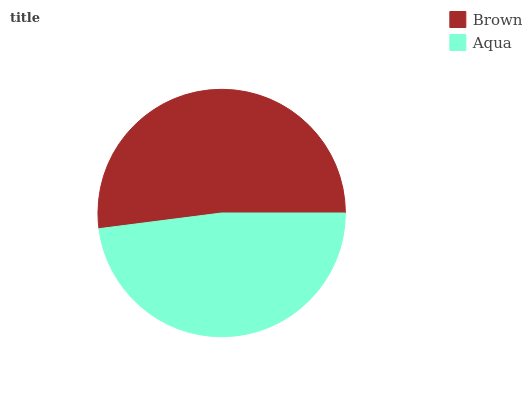Is Aqua the minimum?
Answer yes or no. Yes. Is Brown the maximum?
Answer yes or no. Yes. Is Aqua the maximum?
Answer yes or no. No. Is Brown greater than Aqua?
Answer yes or no. Yes. Is Aqua less than Brown?
Answer yes or no. Yes. Is Aqua greater than Brown?
Answer yes or no. No. Is Brown less than Aqua?
Answer yes or no. No. Is Brown the high median?
Answer yes or no. Yes. Is Aqua the low median?
Answer yes or no. Yes. Is Aqua the high median?
Answer yes or no. No. Is Brown the low median?
Answer yes or no. No. 